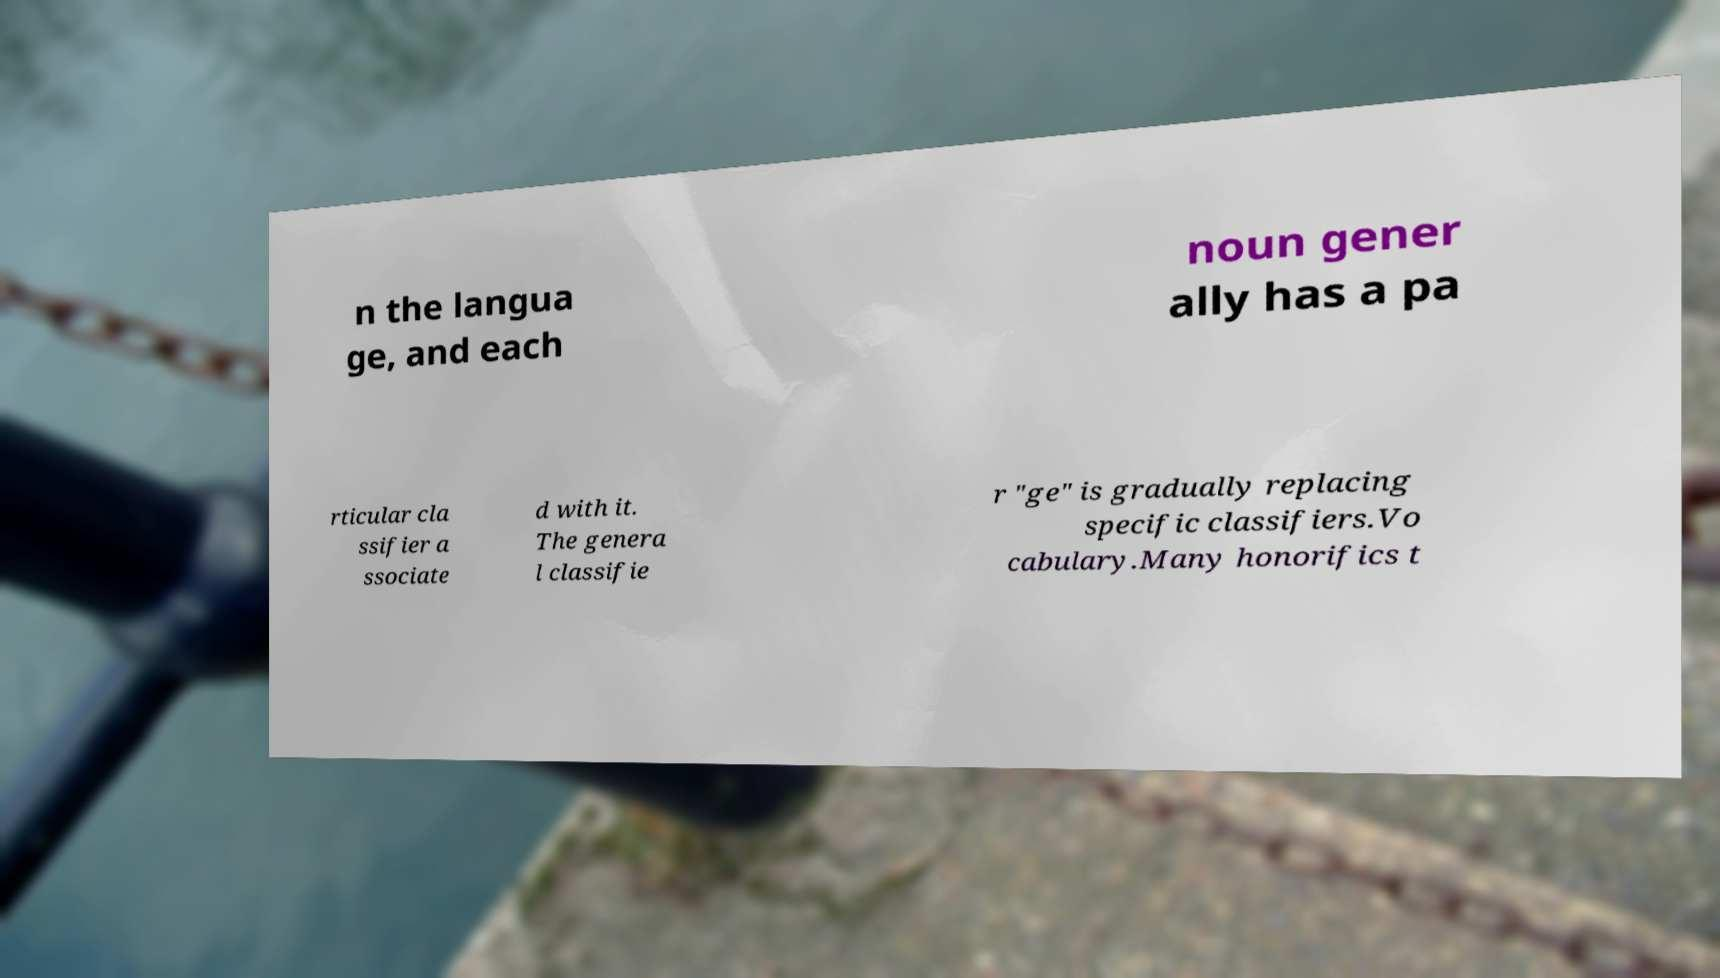Can you accurately transcribe the text from the provided image for me? n the langua ge, and each noun gener ally has a pa rticular cla ssifier a ssociate d with it. The genera l classifie r "ge" is gradually replacing specific classifiers.Vo cabulary.Many honorifics t 